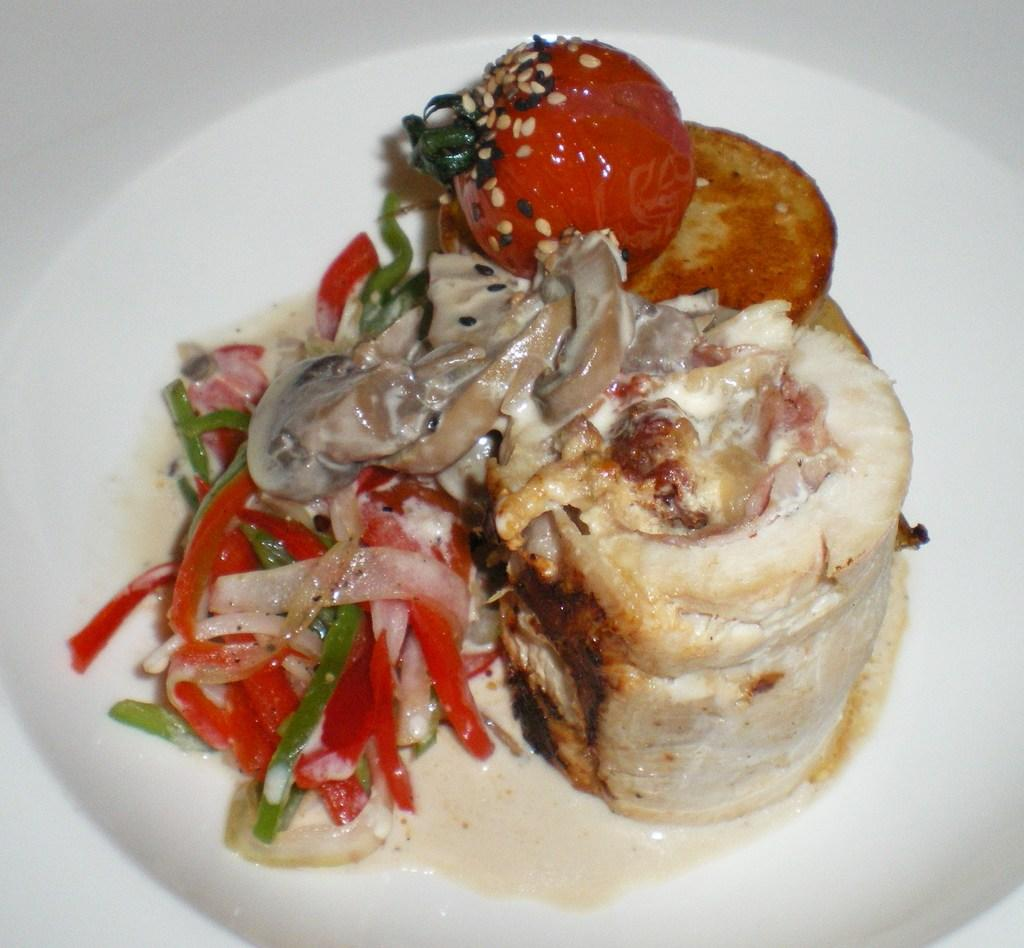What type of food can be seen in the image? The image contains food, but the specific type cannot be determined from the facts provided. What colors are present in the food? The food has red, cream, and green colors. What color is the plate on which the food is served? The plate is white. What type of skin condition can be seen on the food in the image? There is no skin condition present on the food in the image, as the food is not a living organism. 